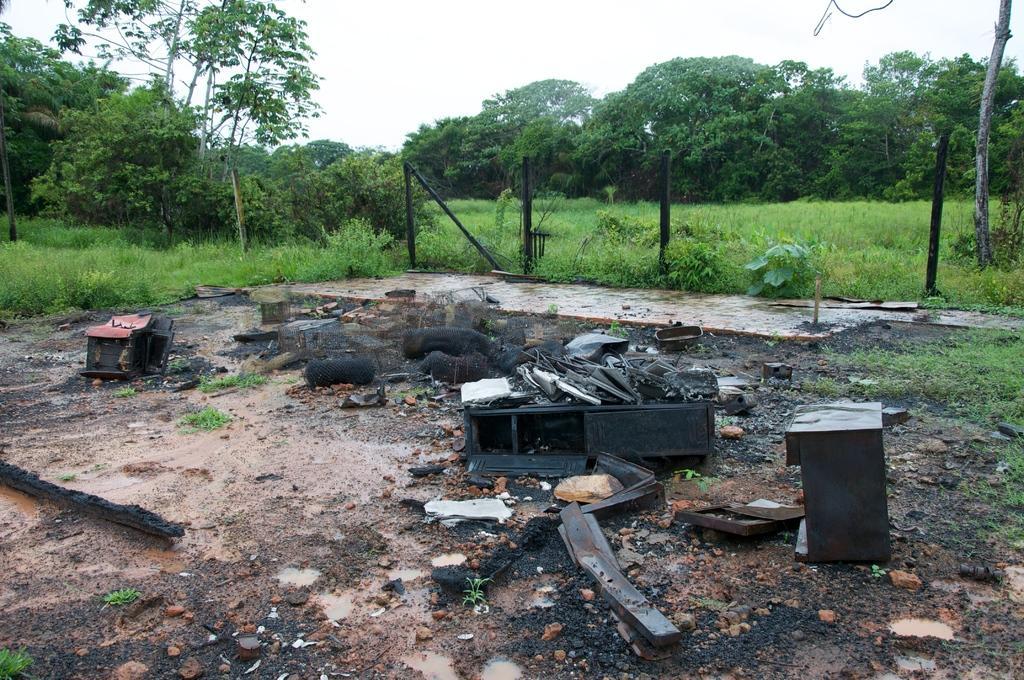In one or two sentences, can you explain what this image depicts? In the center of the image we can see the waste objects. In the background of the image we can see the trees, grass, poles and plants. At the bottom of the image we can see the ground. At the top of the image we can see the sky. 